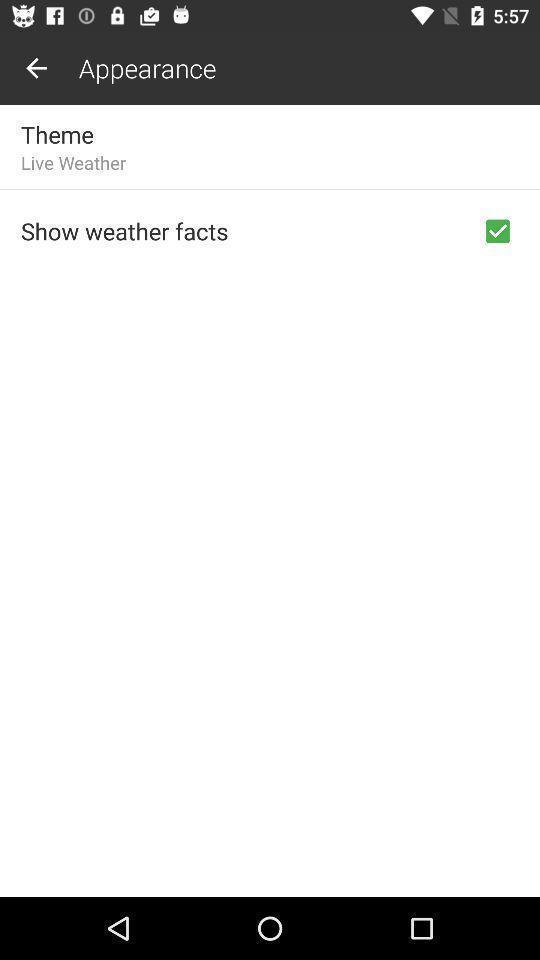Give me a summary of this screen capture. Screen shows appearance with multiple options. 